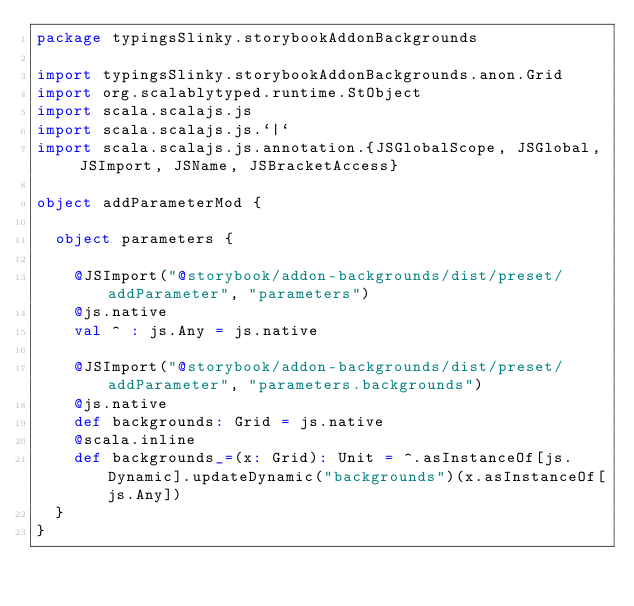<code> <loc_0><loc_0><loc_500><loc_500><_Scala_>package typingsSlinky.storybookAddonBackgrounds

import typingsSlinky.storybookAddonBackgrounds.anon.Grid
import org.scalablytyped.runtime.StObject
import scala.scalajs.js
import scala.scalajs.js.`|`
import scala.scalajs.js.annotation.{JSGlobalScope, JSGlobal, JSImport, JSName, JSBracketAccess}

object addParameterMod {
  
  object parameters {
    
    @JSImport("@storybook/addon-backgrounds/dist/preset/addParameter", "parameters")
    @js.native
    val ^ : js.Any = js.native
    
    @JSImport("@storybook/addon-backgrounds/dist/preset/addParameter", "parameters.backgrounds")
    @js.native
    def backgrounds: Grid = js.native
    @scala.inline
    def backgrounds_=(x: Grid): Unit = ^.asInstanceOf[js.Dynamic].updateDynamic("backgrounds")(x.asInstanceOf[js.Any])
  }
}
</code> 